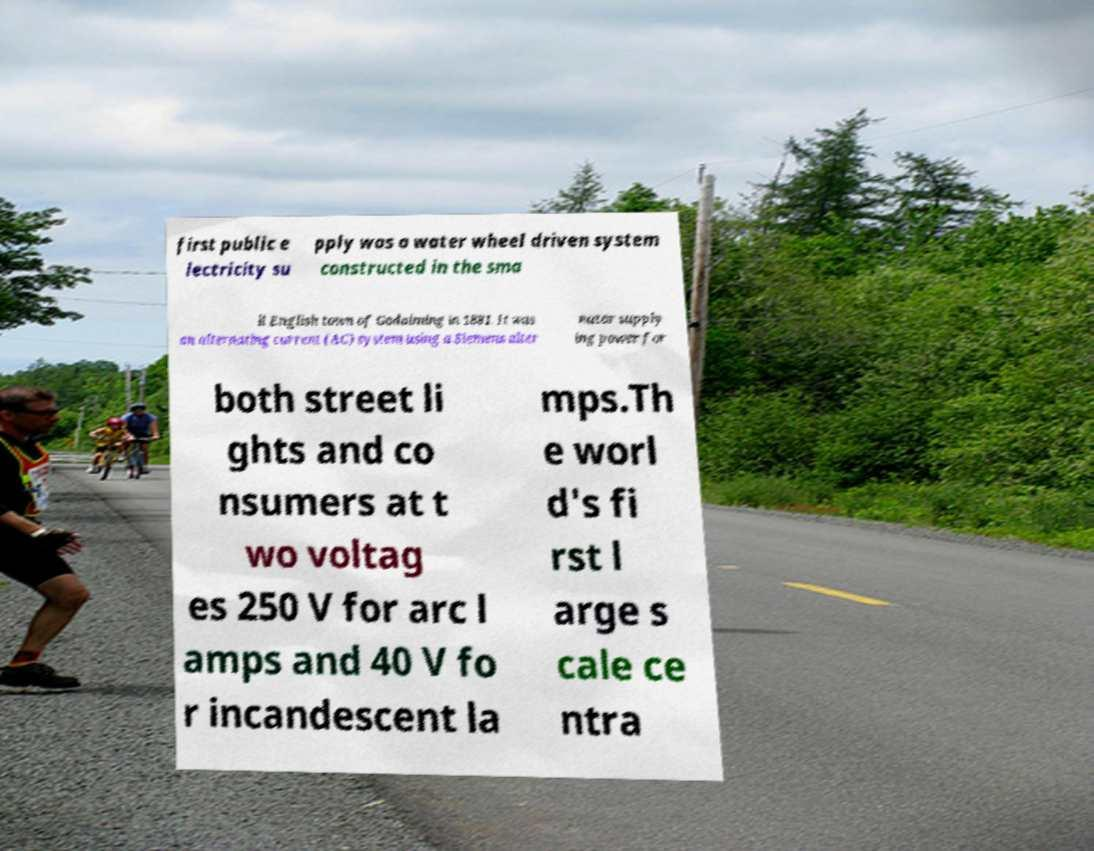Please identify and transcribe the text found in this image. first public e lectricity su pply was a water wheel driven system constructed in the sma ll English town of Godalming in 1881. It was an alternating current (AC) system using a Siemens alter nator supply ing power for both street li ghts and co nsumers at t wo voltag es 250 V for arc l amps and 40 V fo r incandescent la mps.Th e worl d's fi rst l arge s cale ce ntra 